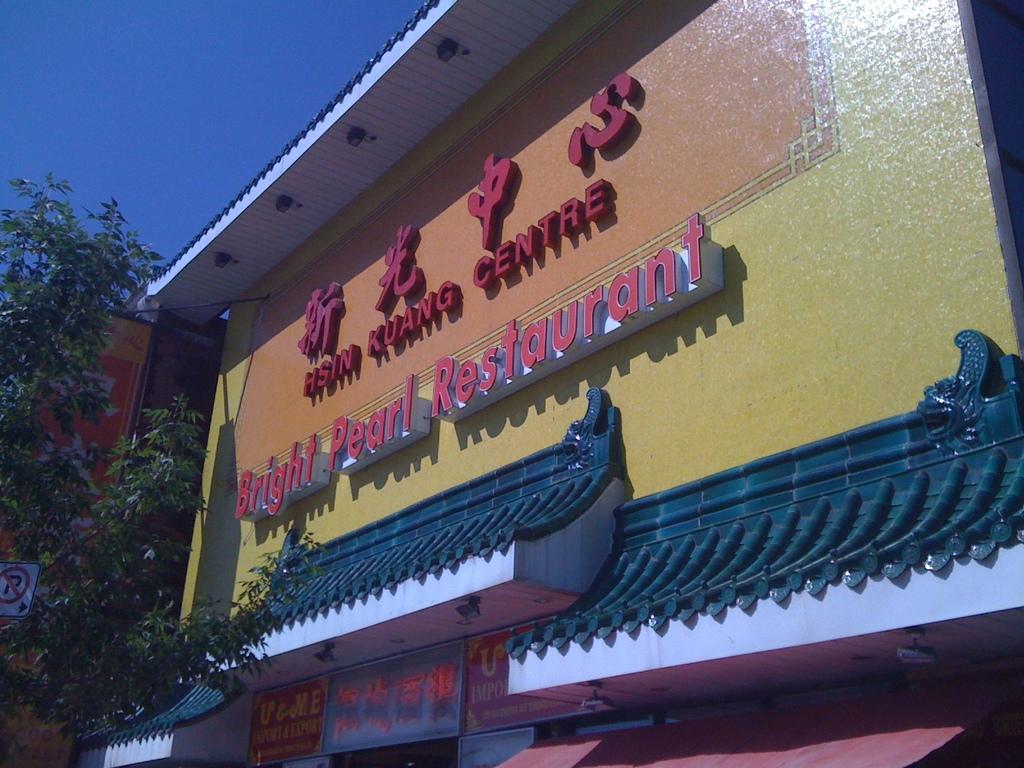What is the chinese writing mean?
Your answer should be compact. Hsin kuang centre. 